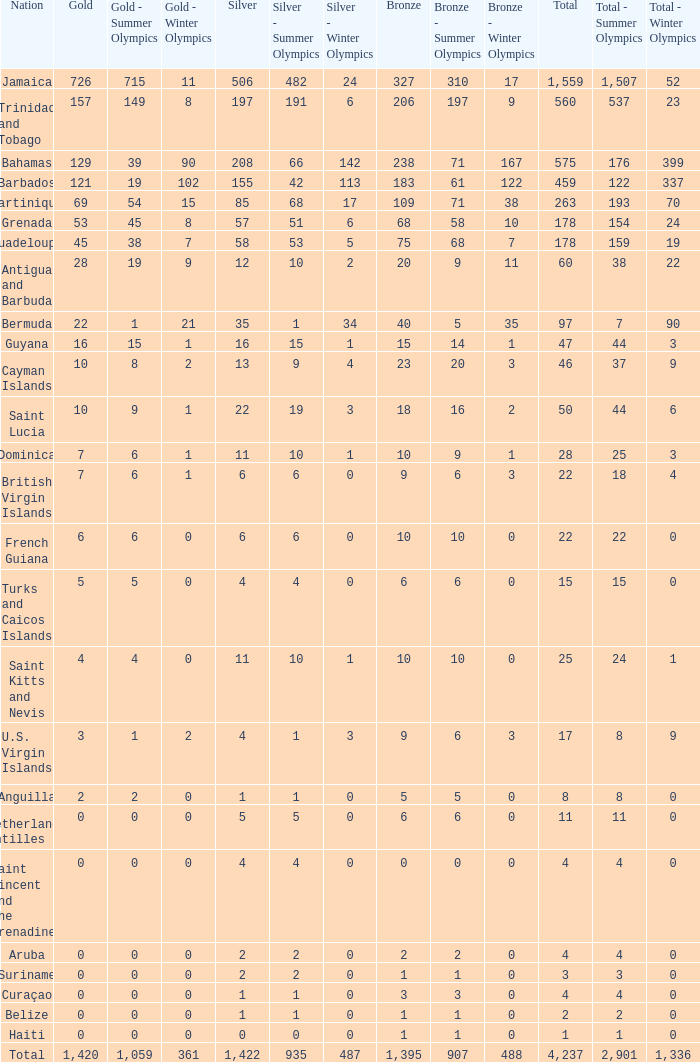What is listed as the highest Silver that also has a Gold of 4 and a Total that's larger than 25? None. 